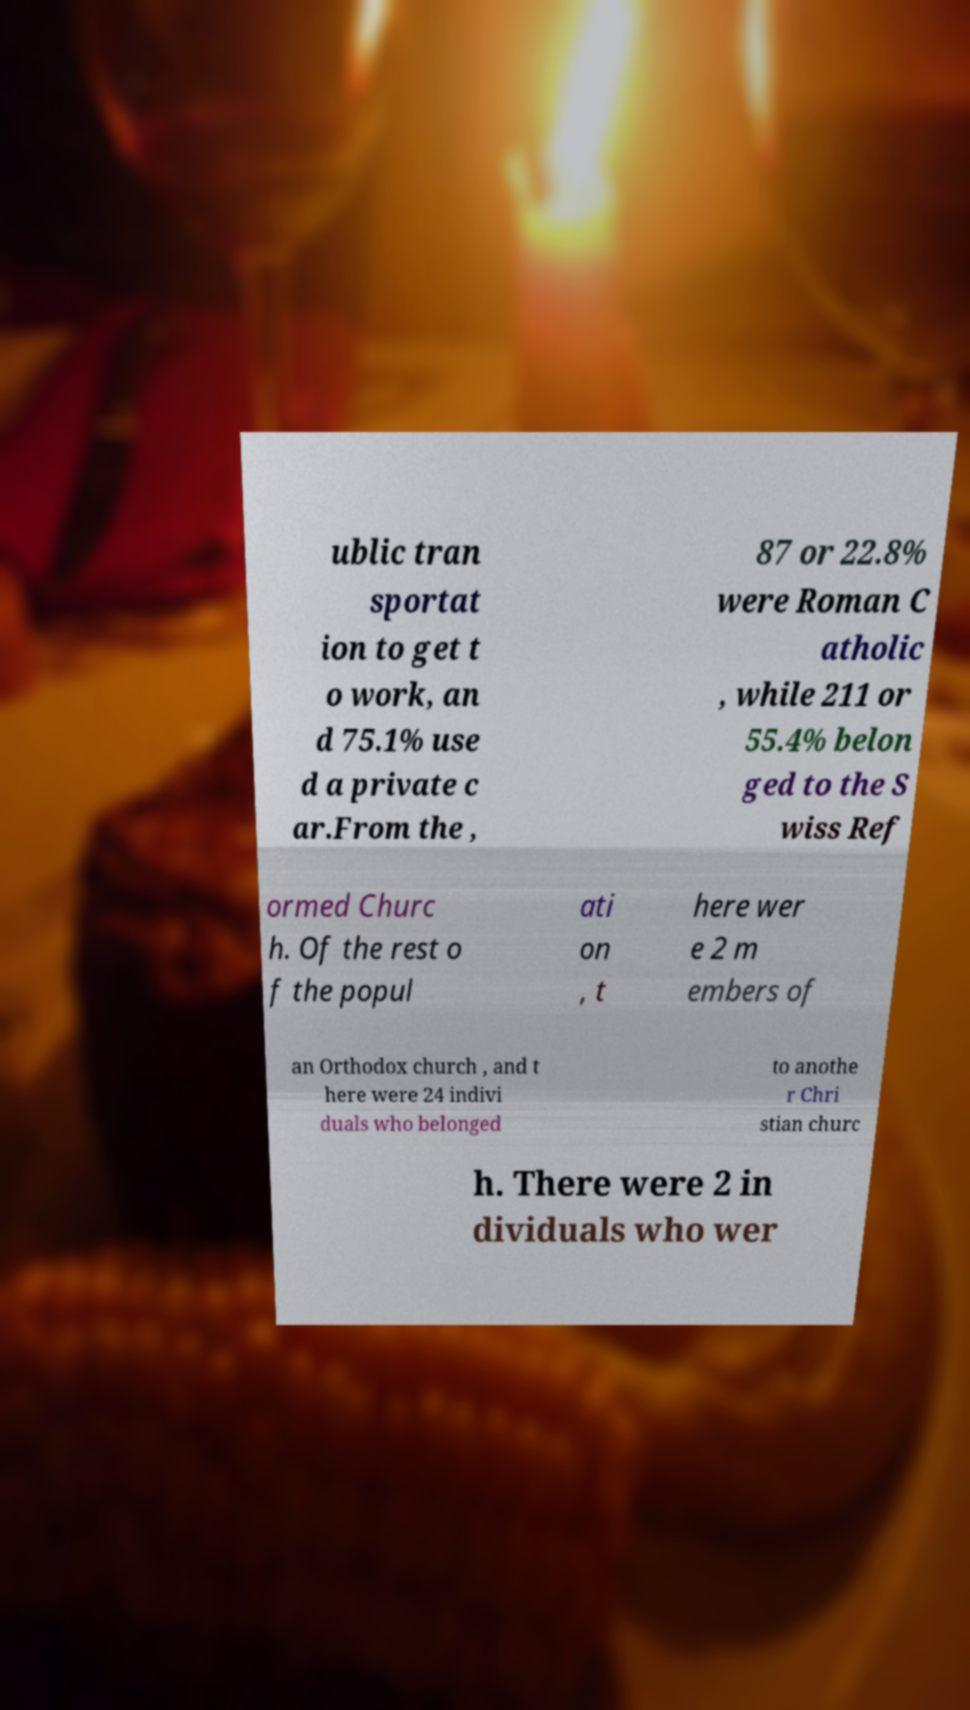What messages or text are displayed in this image? I need them in a readable, typed format. ublic tran sportat ion to get t o work, an d 75.1% use d a private c ar.From the , 87 or 22.8% were Roman C atholic , while 211 or 55.4% belon ged to the S wiss Ref ormed Churc h. Of the rest o f the popul ati on , t here wer e 2 m embers of an Orthodox church , and t here were 24 indivi duals who belonged to anothe r Chri stian churc h. There were 2 in dividuals who wer 